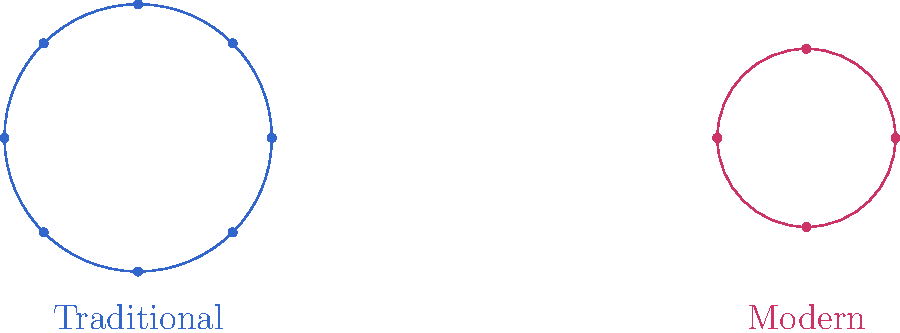In the diagram above, which family structure aligns more closely with the traditional Mormon values of large families and the importance of posterity? To answer this question, we need to consider the following steps:

1. Examine the two family structures presented in the diagram.
2. Identify the key differences between the two structures.
3. Recall traditional Mormon teachings about family size and posterity.
4. Compare these teachings with the structures shown.

The diagram shows two family structures:
- On the left (blue): A larger circle with 8 individual dots.
- On the right (red): A smaller circle with 4 individual dots.

Traditional Mormon teachings emphasize:
1. The importance of large families.
2. The value of posterity and generations.
3. The belief that families can be eternal.

The structure on the left, with its larger size and greater number of individuals, more closely aligns with these traditional values. It represents a larger family unit, which is consistent with the Mormon emphasis on having many children and creating a large posterity.

The structure on the right, being smaller and with fewer individuals, represents a more modern, potentially secular approach to family planning with fewer children.

Therefore, the family structure that aligns more closely with traditional Mormon values is the larger, blue circle on the left.
Answer: The larger, blue circle on the left (Traditional) 